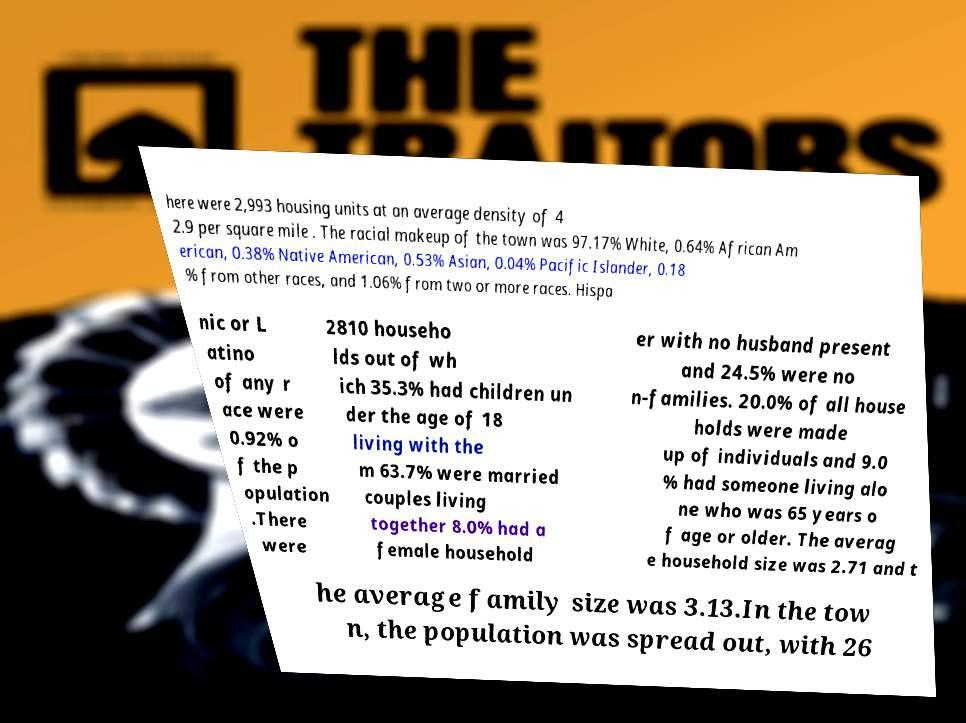Could you assist in decoding the text presented in this image and type it out clearly? here were 2,993 housing units at an average density of 4 2.9 per square mile . The racial makeup of the town was 97.17% White, 0.64% African Am erican, 0.38% Native American, 0.53% Asian, 0.04% Pacific Islander, 0.18 % from other races, and 1.06% from two or more races. Hispa nic or L atino of any r ace were 0.92% o f the p opulation .There were 2810 househo lds out of wh ich 35.3% had children un der the age of 18 living with the m 63.7% were married couples living together 8.0% had a female household er with no husband present and 24.5% were no n-families. 20.0% of all house holds were made up of individuals and 9.0 % had someone living alo ne who was 65 years o f age or older. The averag e household size was 2.71 and t he average family size was 3.13.In the tow n, the population was spread out, with 26 